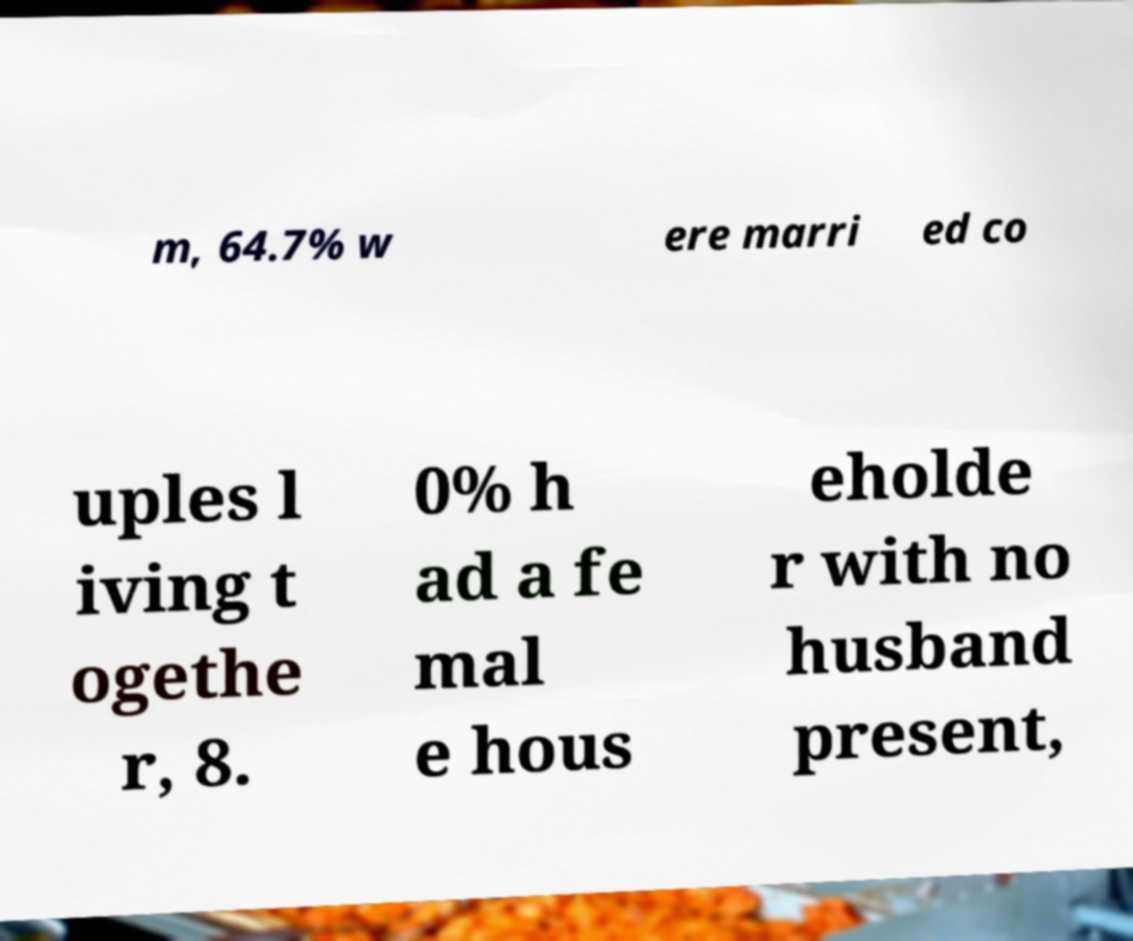There's text embedded in this image that I need extracted. Can you transcribe it verbatim? m, 64.7% w ere marri ed co uples l iving t ogethe r, 8. 0% h ad a fe mal e hous eholde r with no husband present, 